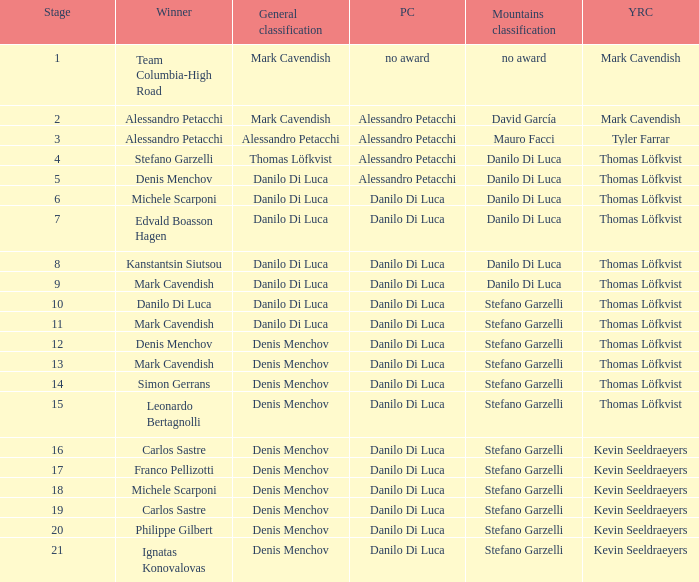When danilo di luca is the winner who is the general classification?  Danilo Di Luca. 